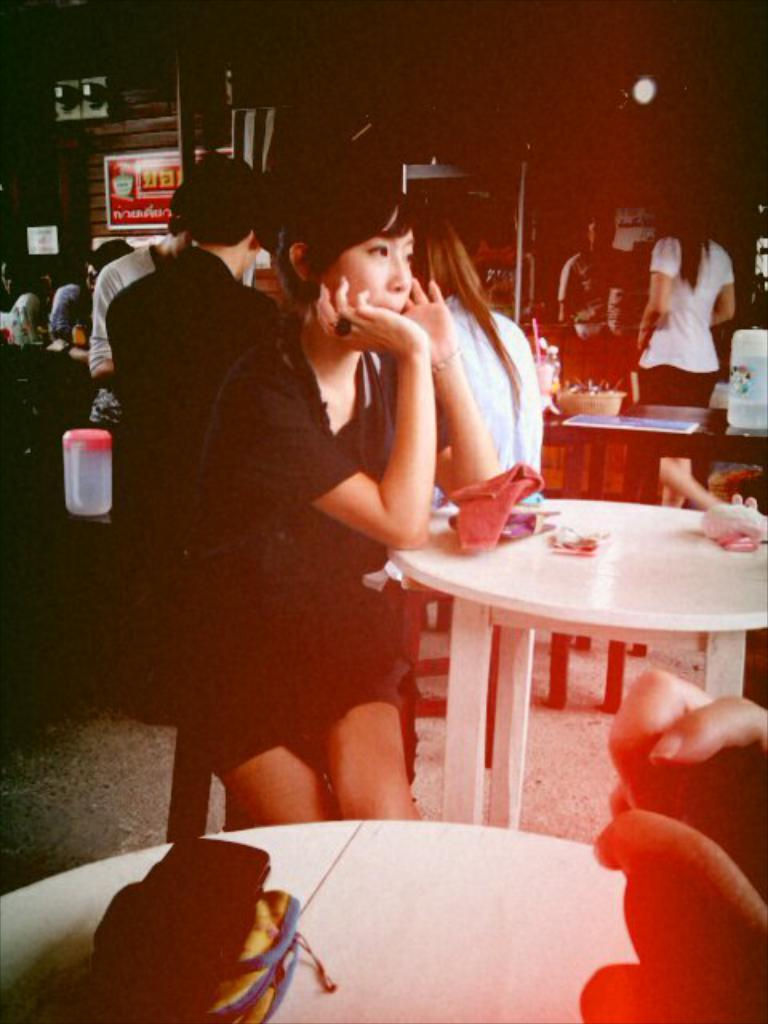What are the people in the image doing? Some people are standing, while others are sitting on chairs in the image. What is on the table in the image? The table has papers on it. How would you describe the lighting in the image? The background of the image is dark. How many frogs can be seen hopping on the papers in the image? There are no frogs present in the image; it only features people standing and sitting, as well as papers on the table. What type of jelly is being used to hold the papers together in the image? There is no jelly visible in the image, and the papers are not being held together by any substance. 